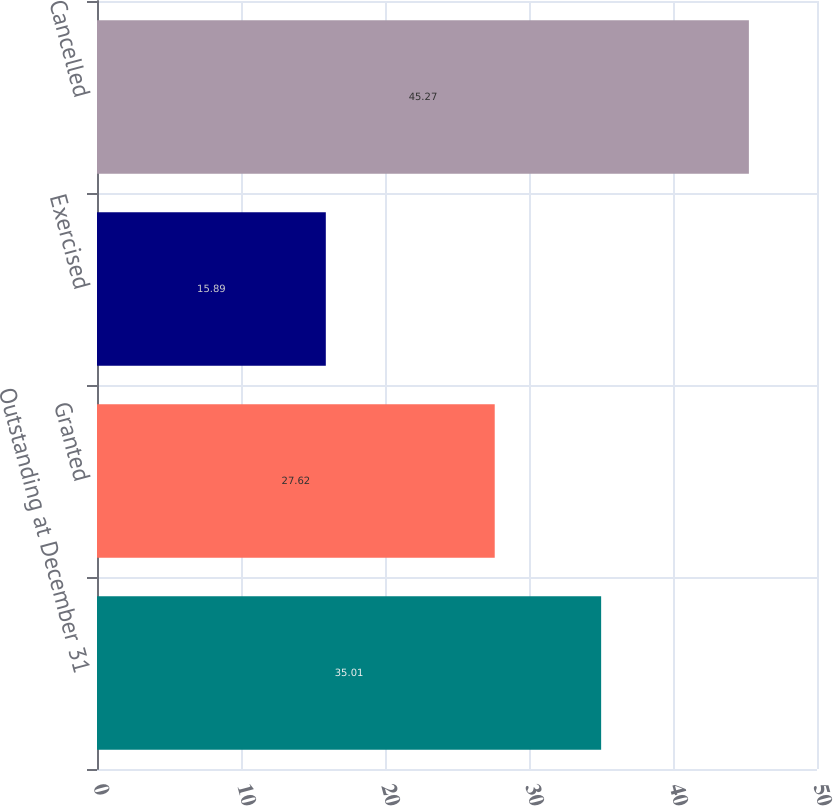Convert chart to OTSL. <chart><loc_0><loc_0><loc_500><loc_500><bar_chart><fcel>Outstanding at December 31<fcel>Granted<fcel>Exercised<fcel>Cancelled<nl><fcel>35.01<fcel>27.62<fcel>15.89<fcel>45.27<nl></chart> 